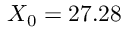Convert formula to latex. <formula><loc_0><loc_0><loc_500><loc_500>X _ { 0 } = 2 7 . 2 8</formula> 